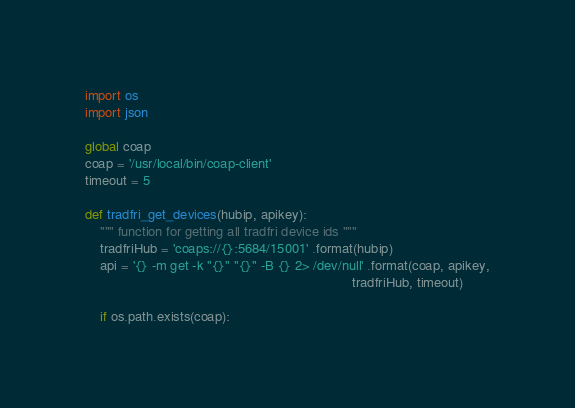Convert code to text. <code><loc_0><loc_0><loc_500><loc_500><_Python_>import os
import json

global coap
coap = '/usr/local/bin/coap-client'
timeout = 5

def tradfri_get_devices(hubip, apikey):
    """ function for getting all tradfri device ids """
    tradfriHub = 'coaps://{}:5684/15001' .format(hubip)
    api = '{} -m get -k "{}" "{}" -B {} 2> /dev/null' .format(coap, apikey,
                                                                      tradfriHub, timeout)

    if os.path.exists(coap):</code> 